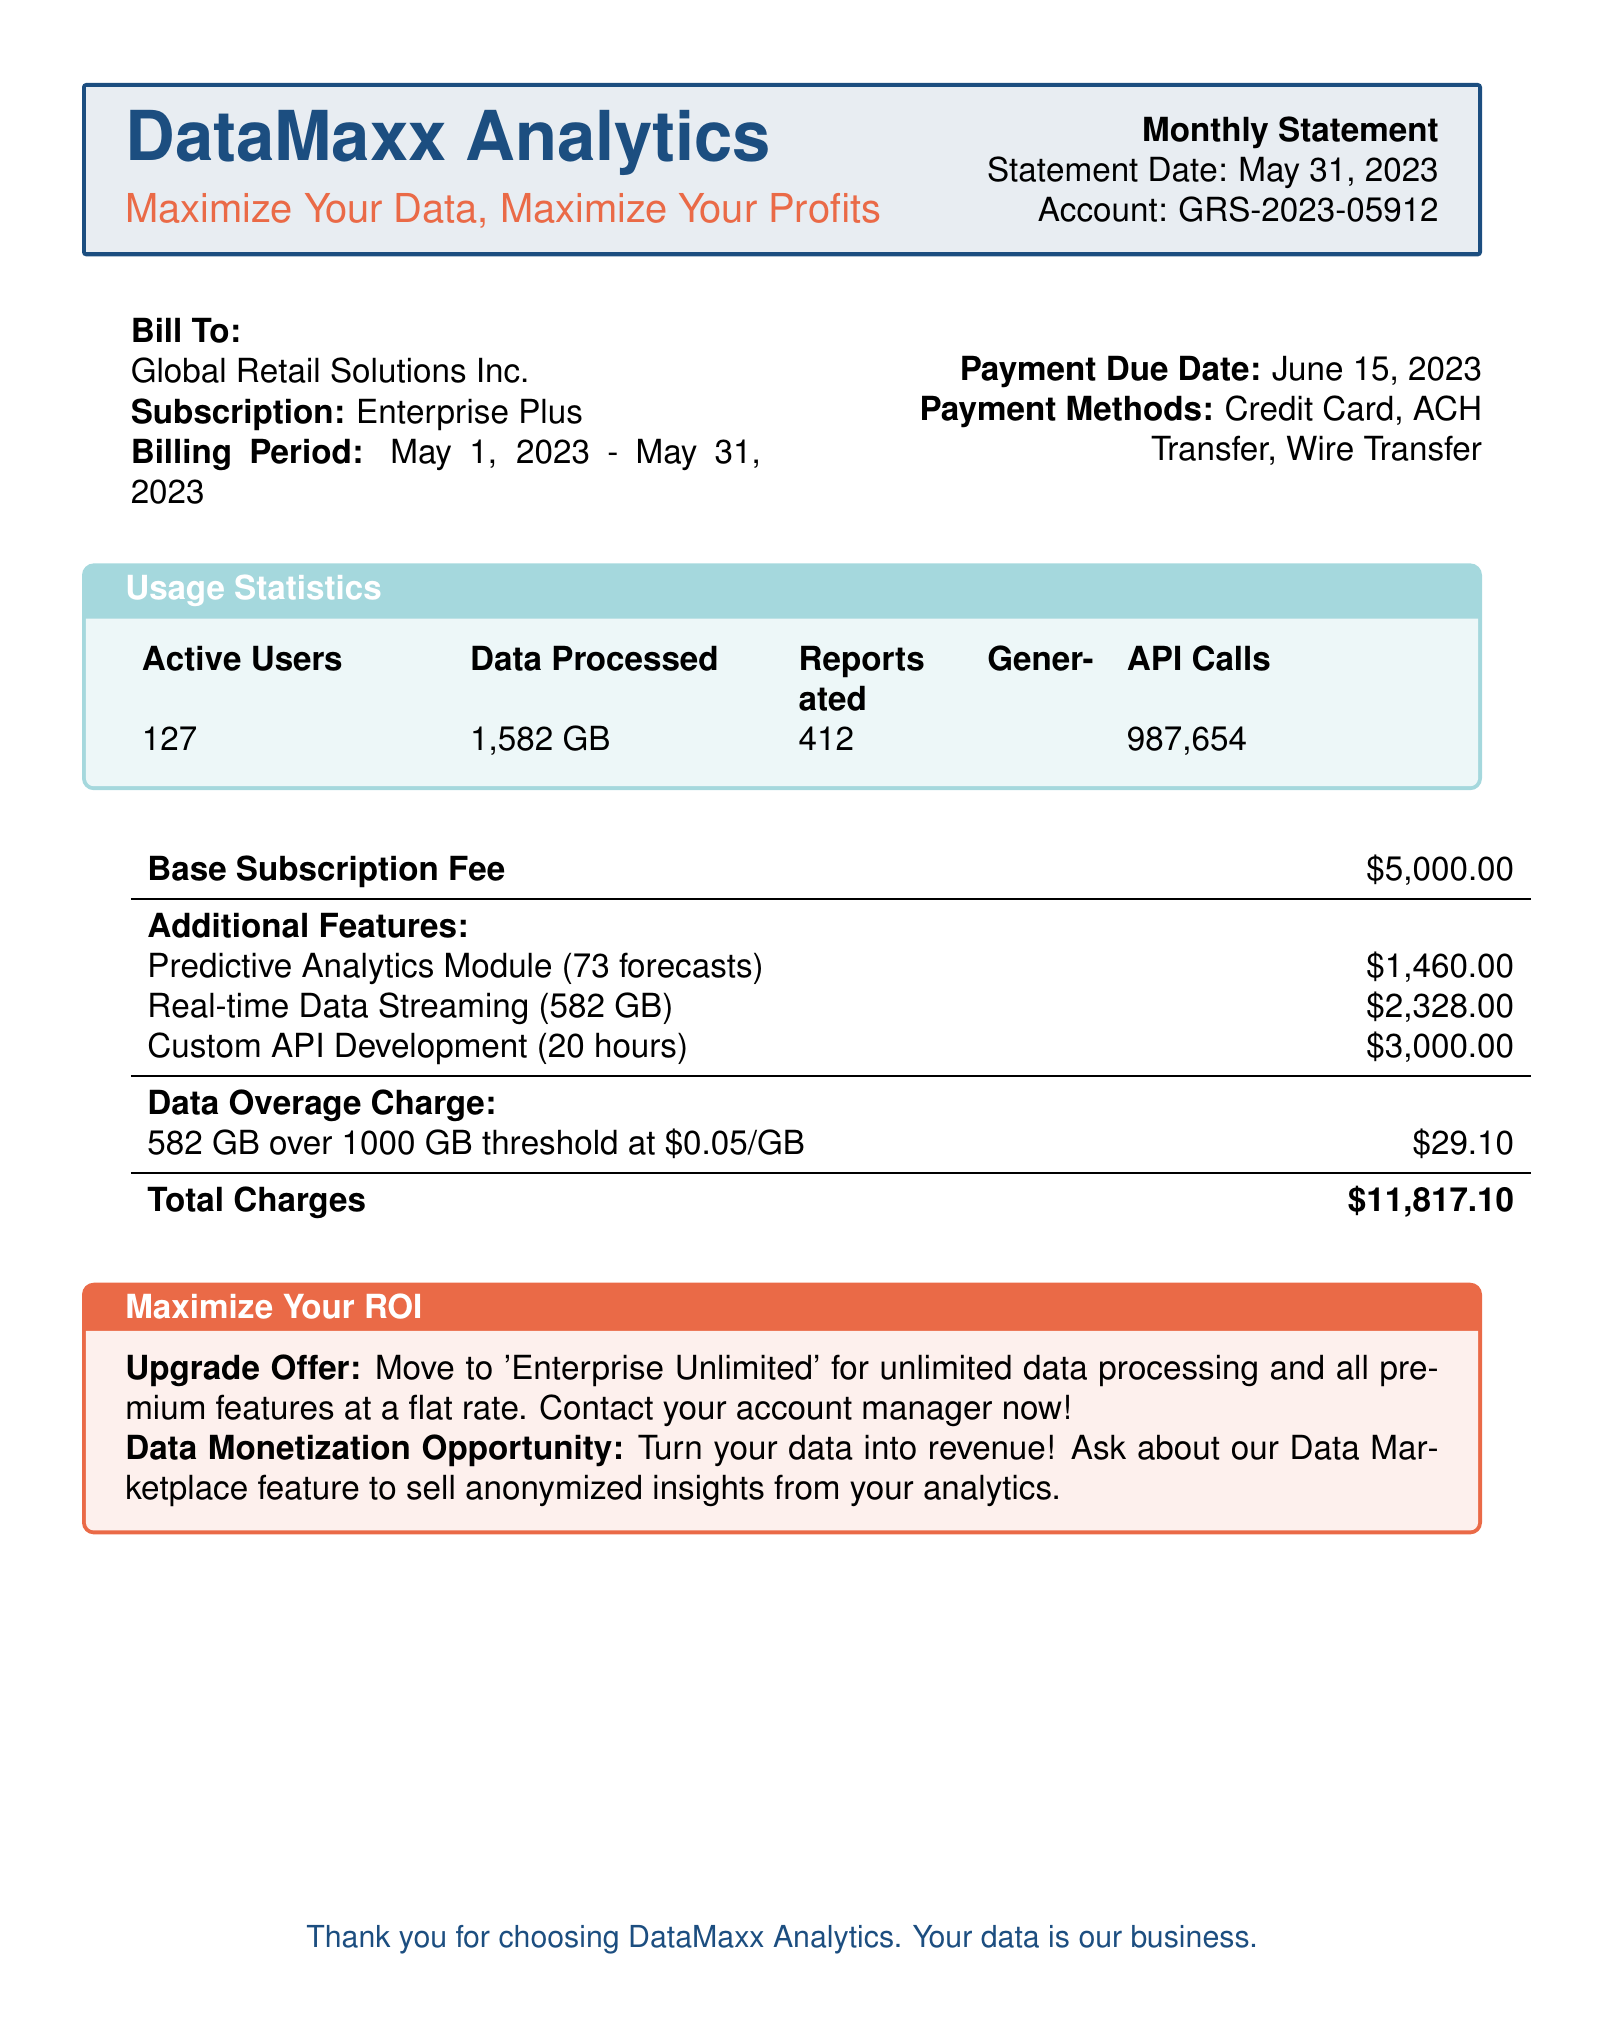What is the billing period? The billing period indicates the time frame covered by this statement, which is from May 1, 2023 to May 31, 2023.
Answer: May 1, 2023 - May 31, 2023 What is the total charge? The total charge is clearly stated at the bottom of the billing summary, which aggregates all fees and charges.
Answer: $11,817.10 How many active users are there? The document specifies the number of active users listed in the usage statistics section.
Answer: 127 What is the account number? The account number is mentioned near the top of the document and is unique to the billing statement.
Answer: GRS-2023-05912 What additional feature costs the most? Among the additional features listed, the cost comparison indicates which one is the highest.
Answer: Custom API Development (20 hours) How much data was processed? The processed data amount is provided in the usage statistics and is a key performance indicator.
Answer: 1,582 GB What is the payment due date? The payment due date informs when the payment should be completed as per the terms of the billing statement.
Answer: June 15, 2023 What is the base subscription fee? The base subscription fee is prominently shown and is typically the main charge in the billing section.
Answer: $5,000.00 What offer is mentioned to maximize ROI? The offer refers to a feature that encourages upgrading to improve the return on investment from services offered.
Answer: Upgrade Offer: Move to 'Enterprise Unlimited' How many API calls were made? The number of API calls is reflected in the usage statistics section, showcasing the extent of software use.
Answer: 987,654 